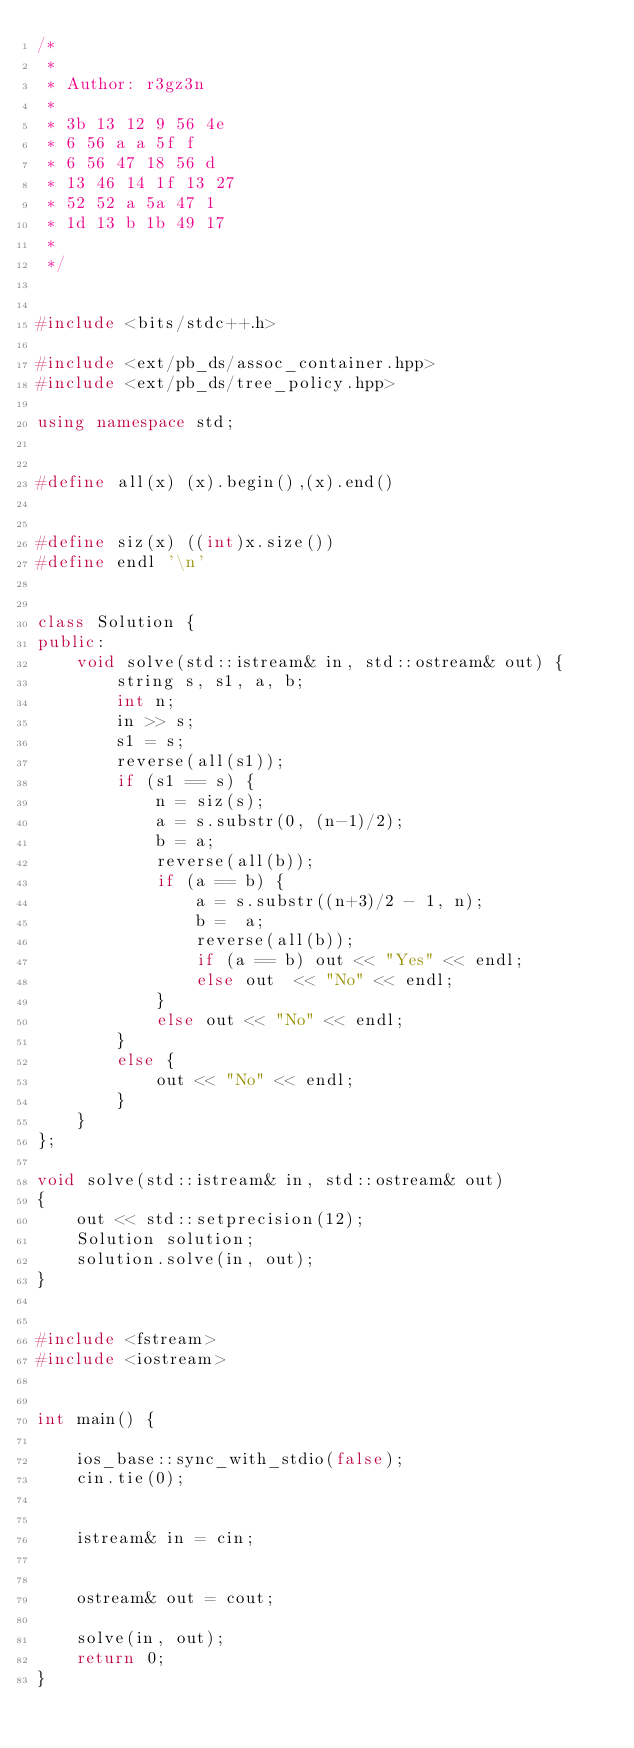<code> <loc_0><loc_0><loc_500><loc_500><_C++_>/*
 *
 * Author: r3gz3n
 * 
 * 3b 13 12 9 56 4e
 * 6 56 a a 5f f
 * 6 56 47 18 56 d
 * 13 46 14 1f 13 27
 * 52 52 a 5a 47 1
 * 1d 13 b 1b 49 17
 *
 */


#include <bits/stdc++.h>

#include <ext/pb_ds/assoc_container.hpp>
#include <ext/pb_ds/tree_policy.hpp>

using namespace std;


#define all(x) (x).begin(),(x).end()


#define siz(x) ((int)x.size())
#define endl '\n'


class Solution {
public:
    void solve(std::istream& in, std::ostream& out) {
        string s, s1, a, b;
        int n;
        in >> s;
        s1 = s;
        reverse(all(s1));
        if (s1 == s) {
            n = siz(s);
            a = s.substr(0, (n-1)/2);
            b = a;
            reverse(all(b)); 
            if (a == b) {
                a = s.substr((n+3)/2 - 1, n);
                b =  a;
                reverse(all(b));
                if (a == b) out << "Yes" << endl;
                else out  << "No" << endl;
            }
            else out << "No" << endl;
        }
        else {
            out << "No" << endl;
        }
    }
};

void solve(std::istream& in, std::ostream& out)
{
    out << std::setprecision(12);
    Solution solution;
    solution.solve(in, out);
}


#include <fstream>
#include <iostream>


int main() {
    
    ios_base::sync_with_stdio(false);
    cin.tie(0);


    istream& in = cin;


    ostream& out = cout;

    solve(in, out);
    return 0;
}


</code> 